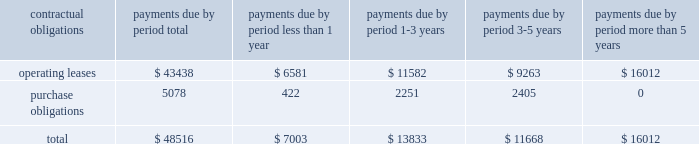Approved by the board of directors on april 21 , 2004 and expired on april 30 , 2006 .
Sources and uses in financing activities during 2005 related primarily to uses for the payment of a dividend ( $ 54.0 million ) and stock repurchase ( $ 26.7 million ) , and a source of cash from the issuance of common shares related to the exercise of employee stock options , the related tax benefit , and the employee stock purchase plan ( $ 9.7 million ) .
Cash dividends paid to shareholders were $ 162.5 million , $ 107.9 million , and $ 54.0 million during fiscal years 2007 , 2006 , and 2005 , respectively .
We believe that our existing cash balances and cash flow from operations will be sufficient to meet our projected capital expenditures , working capital and other cash requirements at least through the end of fiscal 2010 .
Contractual obligations and commercial commitments future commitments of garmin , as of december 29 , 2007 , aggregated by type of contractual obligation .
Operating leases describes lease obligations associated with garmin facilities located in the u.s. , taiwan , the u.k. , and canada .
Purchase obligations are the aggregate of those purchase orders that were outstanding on december 29 , 2007 ; these obligations are created and then paid off within 3 months during the normal course of our manufacturing business .
Off-balance sheet arrangements we do not have any off-balance sheet arrangements .
Item 7a .
Quantitative and qualitative disclosures about market risk market sensitivity we have market risk primarily in connection with the pricing of our products and services and the purchase of raw materials .
Product pricing and raw materials costs are both significantly influenced by semiconductor market conditions .
Historically , during cyclical industry downturns , we have been able to offset pricing declines for our products through a combination of improved product mix and success in obtaining price reductions in raw materials costs .
Inflation we do not believe that inflation has had a material effect on our business , financial condition or results of operations .
If our costs were to become subject to significant inflationary pressures , we may not be able to fully offset such higher costs through price increases .
Our inability or failure to do so could adversely affect our business , financial condition and results of operations .
Foreign currency exchange rate risk the operation of garmin 2019s subsidiaries in international markets results in exposure to movements in currency exchange rates .
We generally have not been significantly affected by foreign exchange fluctuations .
What percentage of total contractual obligations and commercial commitments future commitments of garmin , as of december 29 , 2007 are due to purchase obligations? 
Computations: (5078 / 48516)
Answer: 0.10467. 